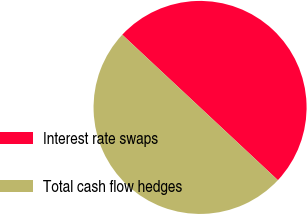Convert chart. <chart><loc_0><loc_0><loc_500><loc_500><pie_chart><fcel>Interest rate swaps<fcel>Total cash flow hedges<nl><fcel>50.0%<fcel>50.0%<nl></chart> 